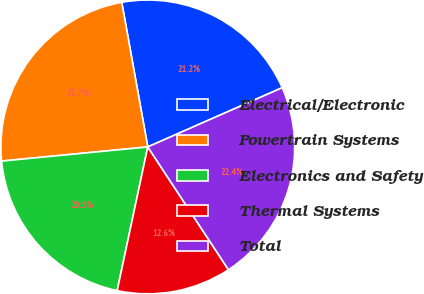Convert chart to OTSL. <chart><loc_0><loc_0><loc_500><loc_500><pie_chart><fcel>Electrical/Electronic<fcel>Powertrain Systems<fcel>Electronics and Safety<fcel>Thermal Systems<fcel>Total<nl><fcel>21.23%<fcel>23.7%<fcel>20.12%<fcel>12.59%<fcel>22.35%<nl></chart> 